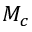Convert formula to latex. <formula><loc_0><loc_0><loc_500><loc_500>M _ { c }</formula> 